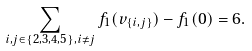Convert formula to latex. <formula><loc_0><loc_0><loc_500><loc_500>\sum _ { i , j \in \{ 2 , 3 , 4 , 5 \} , i \neq j } f _ { 1 } ( v _ { \{ i , j \} } ) - f _ { 1 } ( 0 ) = 6 .</formula> 